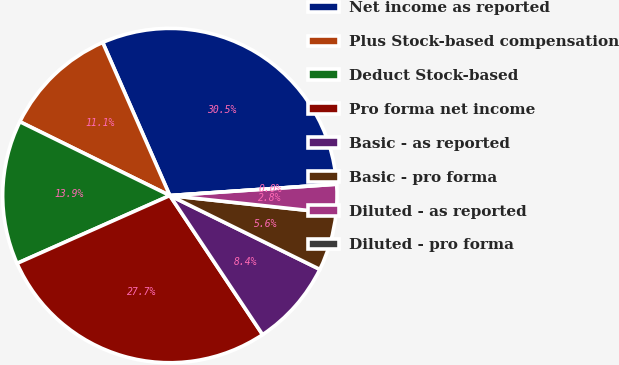Convert chart. <chart><loc_0><loc_0><loc_500><loc_500><pie_chart><fcel>Net income as reported<fcel>Plus Stock-based compensation<fcel>Deduct Stock-based<fcel>Pro forma net income<fcel>Basic - as reported<fcel>Basic - pro forma<fcel>Diluted - as reported<fcel>Diluted - pro forma<nl><fcel>30.5%<fcel>11.14%<fcel>13.93%<fcel>27.71%<fcel>8.36%<fcel>5.57%<fcel>2.79%<fcel>0.0%<nl></chart> 